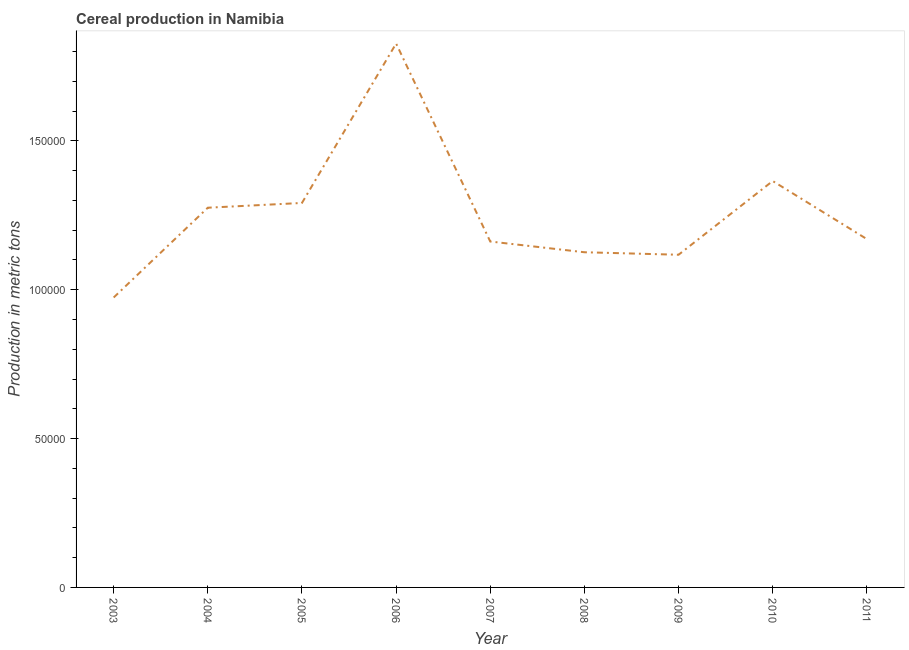What is the cereal production in 2007?
Keep it short and to the point. 1.16e+05. Across all years, what is the maximum cereal production?
Your answer should be very brief. 1.83e+05. Across all years, what is the minimum cereal production?
Give a very brief answer. 9.74e+04. In which year was the cereal production maximum?
Your response must be concise. 2006. In which year was the cereal production minimum?
Keep it short and to the point. 2003. What is the sum of the cereal production?
Your answer should be very brief. 1.13e+06. What is the difference between the cereal production in 2004 and 2006?
Provide a succinct answer. -5.51e+04. What is the average cereal production per year?
Keep it short and to the point. 1.26e+05. What is the median cereal production?
Provide a succinct answer. 1.17e+05. What is the ratio of the cereal production in 2003 to that in 2011?
Provide a short and direct response. 0.83. Is the cereal production in 2003 less than that in 2007?
Your response must be concise. Yes. Is the difference between the cereal production in 2003 and 2010 greater than the difference between any two years?
Make the answer very short. No. What is the difference between the highest and the second highest cereal production?
Make the answer very short. 4.62e+04. What is the difference between the highest and the lowest cereal production?
Ensure brevity in your answer.  8.53e+04. Does the cereal production monotonically increase over the years?
Make the answer very short. No. How many lines are there?
Provide a succinct answer. 1. How many years are there in the graph?
Provide a succinct answer. 9. What is the difference between two consecutive major ticks on the Y-axis?
Keep it short and to the point. 5.00e+04. Does the graph contain any zero values?
Make the answer very short. No. Does the graph contain grids?
Ensure brevity in your answer.  No. What is the title of the graph?
Make the answer very short. Cereal production in Namibia. What is the label or title of the Y-axis?
Your response must be concise. Production in metric tons. What is the Production in metric tons in 2003?
Provide a short and direct response. 9.74e+04. What is the Production in metric tons of 2004?
Give a very brief answer. 1.28e+05. What is the Production in metric tons in 2005?
Offer a terse response. 1.29e+05. What is the Production in metric tons of 2006?
Provide a short and direct response. 1.83e+05. What is the Production in metric tons in 2007?
Offer a terse response. 1.16e+05. What is the Production in metric tons in 2008?
Offer a terse response. 1.13e+05. What is the Production in metric tons of 2009?
Your response must be concise. 1.12e+05. What is the Production in metric tons of 2010?
Provide a short and direct response. 1.36e+05. What is the Production in metric tons of 2011?
Give a very brief answer. 1.17e+05. What is the difference between the Production in metric tons in 2003 and 2004?
Your answer should be very brief. -3.02e+04. What is the difference between the Production in metric tons in 2003 and 2005?
Provide a succinct answer. -3.18e+04. What is the difference between the Production in metric tons in 2003 and 2006?
Your answer should be very brief. -8.53e+04. What is the difference between the Production in metric tons in 2003 and 2007?
Your answer should be compact. -1.88e+04. What is the difference between the Production in metric tons in 2003 and 2008?
Offer a very short reply. -1.52e+04. What is the difference between the Production in metric tons in 2003 and 2009?
Offer a very short reply. -1.44e+04. What is the difference between the Production in metric tons in 2003 and 2010?
Give a very brief answer. -3.91e+04. What is the difference between the Production in metric tons in 2003 and 2011?
Your response must be concise. -1.96e+04. What is the difference between the Production in metric tons in 2004 and 2005?
Ensure brevity in your answer.  -1603. What is the difference between the Production in metric tons in 2004 and 2006?
Offer a terse response. -5.51e+04. What is the difference between the Production in metric tons in 2004 and 2007?
Provide a succinct answer. 1.14e+04. What is the difference between the Production in metric tons in 2004 and 2008?
Provide a short and direct response. 1.50e+04. What is the difference between the Production in metric tons in 2004 and 2009?
Make the answer very short. 1.58e+04. What is the difference between the Production in metric tons in 2004 and 2010?
Your answer should be very brief. -8965. What is the difference between the Production in metric tons in 2004 and 2011?
Offer a terse response. 1.05e+04. What is the difference between the Production in metric tons in 2005 and 2006?
Provide a succinct answer. -5.35e+04. What is the difference between the Production in metric tons in 2005 and 2007?
Your answer should be compact. 1.30e+04. What is the difference between the Production in metric tons in 2005 and 2008?
Your answer should be very brief. 1.66e+04. What is the difference between the Production in metric tons in 2005 and 2009?
Give a very brief answer. 1.74e+04. What is the difference between the Production in metric tons in 2005 and 2010?
Give a very brief answer. -7362. What is the difference between the Production in metric tons in 2005 and 2011?
Make the answer very short. 1.21e+04. What is the difference between the Production in metric tons in 2006 and 2007?
Your response must be concise. 6.65e+04. What is the difference between the Production in metric tons in 2006 and 2008?
Your response must be concise. 7.01e+04. What is the difference between the Production in metric tons in 2006 and 2009?
Your response must be concise. 7.09e+04. What is the difference between the Production in metric tons in 2006 and 2010?
Make the answer very short. 4.62e+04. What is the difference between the Production in metric tons in 2006 and 2011?
Your answer should be very brief. 6.57e+04. What is the difference between the Production in metric tons in 2007 and 2008?
Offer a terse response. 3603. What is the difference between the Production in metric tons in 2007 and 2009?
Keep it short and to the point. 4445. What is the difference between the Production in metric tons in 2007 and 2010?
Your answer should be very brief. -2.03e+04. What is the difference between the Production in metric tons in 2007 and 2011?
Provide a short and direct response. -817. What is the difference between the Production in metric tons in 2008 and 2009?
Offer a terse response. 842. What is the difference between the Production in metric tons in 2008 and 2010?
Make the answer very short. -2.39e+04. What is the difference between the Production in metric tons in 2008 and 2011?
Provide a short and direct response. -4420. What is the difference between the Production in metric tons in 2009 and 2010?
Ensure brevity in your answer.  -2.48e+04. What is the difference between the Production in metric tons in 2009 and 2011?
Offer a very short reply. -5262. What is the difference between the Production in metric tons in 2010 and 2011?
Give a very brief answer. 1.95e+04. What is the ratio of the Production in metric tons in 2003 to that in 2004?
Your answer should be compact. 0.76. What is the ratio of the Production in metric tons in 2003 to that in 2005?
Provide a succinct answer. 0.75. What is the ratio of the Production in metric tons in 2003 to that in 2006?
Your response must be concise. 0.53. What is the ratio of the Production in metric tons in 2003 to that in 2007?
Offer a very short reply. 0.84. What is the ratio of the Production in metric tons in 2003 to that in 2008?
Ensure brevity in your answer.  0.86. What is the ratio of the Production in metric tons in 2003 to that in 2009?
Ensure brevity in your answer.  0.87. What is the ratio of the Production in metric tons in 2003 to that in 2010?
Make the answer very short. 0.71. What is the ratio of the Production in metric tons in 2003 to that in 2011?
Your answer should be very brief. 0.83. What is the ratio of the Production in metric tons in 2004 to that in 2006?
Give a very brief answer. 0.7. What is the ratio of the Production in metric tons in 2004 to that in 2007?
Offer a terse response. 1.1. What is the ratio of the Production in metric tons in 2004 to that in 2008?
Provide a succinct answer. 1.13. What is the ratio of the Production in metric tons in 2004 to that in 2009?
Your answer should be compact. 1.14. What is the ratio of the Production in metric tons in 2004 to that in 2010?
Give a very brief answer. 0.93. What is the ratio of the Production in metric tons in 2004 to that in 2011?
Keep it short and to the point. 1.09. What is the ratio of the Production in metric tons in 2005 to that in 2006?
Give a very brief answer. 0.71. What is the ratio of the Production in metric tons in 2005 to that in 2007?
Ensure brevity in your answer.  1.11. What is the ratio of the Production in metric tons in 2005 to that in 2008?
Provide a succinct answer. 1.15. What is the ratio of the Production in metric tons in 2005 to that in 2009?
Make the answer very short. 1.16. What is the ratio of the Production in metric tons in 2005 to that in 2010?
Offer a very short reply. 0.95. What is the ratio of the Production in metric tons in 2005 to that in 2011?
Give a very brief answer. 1.1. What is the ratio of the Production in metric tons in 2006 to that in 2007?
Your answer should be compact. 1.57. What is the ratio of the Production in metric tons in 2006 to that in 2008?
Provide a succinct answer. 1.62. What is the ratio of the Production in metric tons in 2006 to that in 2009?
Ensure brevity in your answer.  1.64. What is the ratio of the Production in metric tons in 2006 to that in 2010?
Keep it short and to the point. 1.34. What is the ratio of the Production in metric tons in 2006 to that in 2011?
Offer a terse response. 1.56. What is the ratio of the Production in metric tons in 2007 to that in 2008?
Keep it short and to the point. 1.03. What is the ratio of the Production in metric tons in 2007 to that in 2009?
Ensure brevity in your answer.  1.04. What is the ratio of the Production in metric tons in 2007 to that in 2010?
Your response must be concise. 0.85. What is the ratio of the Production in metric tons in 2007 to that in 2011?
Give a very brief answer. 0.99. What is the ratio of the Production in metric tons in 2008 to that in 2010?
Your response must be concise. 0.82. What is the ratio of the Production in metric tons in 2008 to that in 2011?
Offer a terse response. 0.96. What is the ratio of the Production in metric tons in 2009 to that in 2010?
Provide a succinct answer. 0.82. What is the ratio of the Production in metric tons in 2009 to that in 2011?
Give a very brief answer. 0.95. What is the ratio of the Production in metric tons in 2010 to that in 2011?
Your answer should be compact. 1.17. 